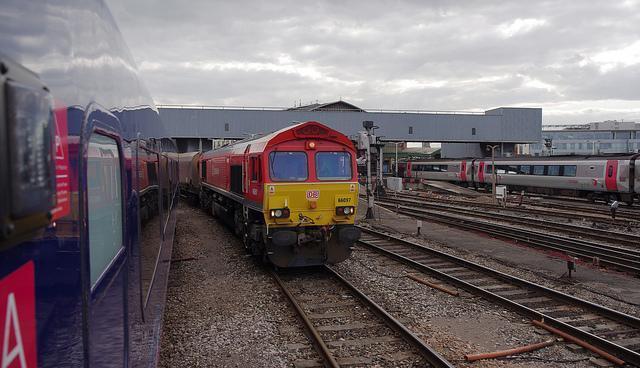How many train cars are easily visible?
Give a very brief answer. 4. How many trains are visible?
Give a very brief answer. 3. 